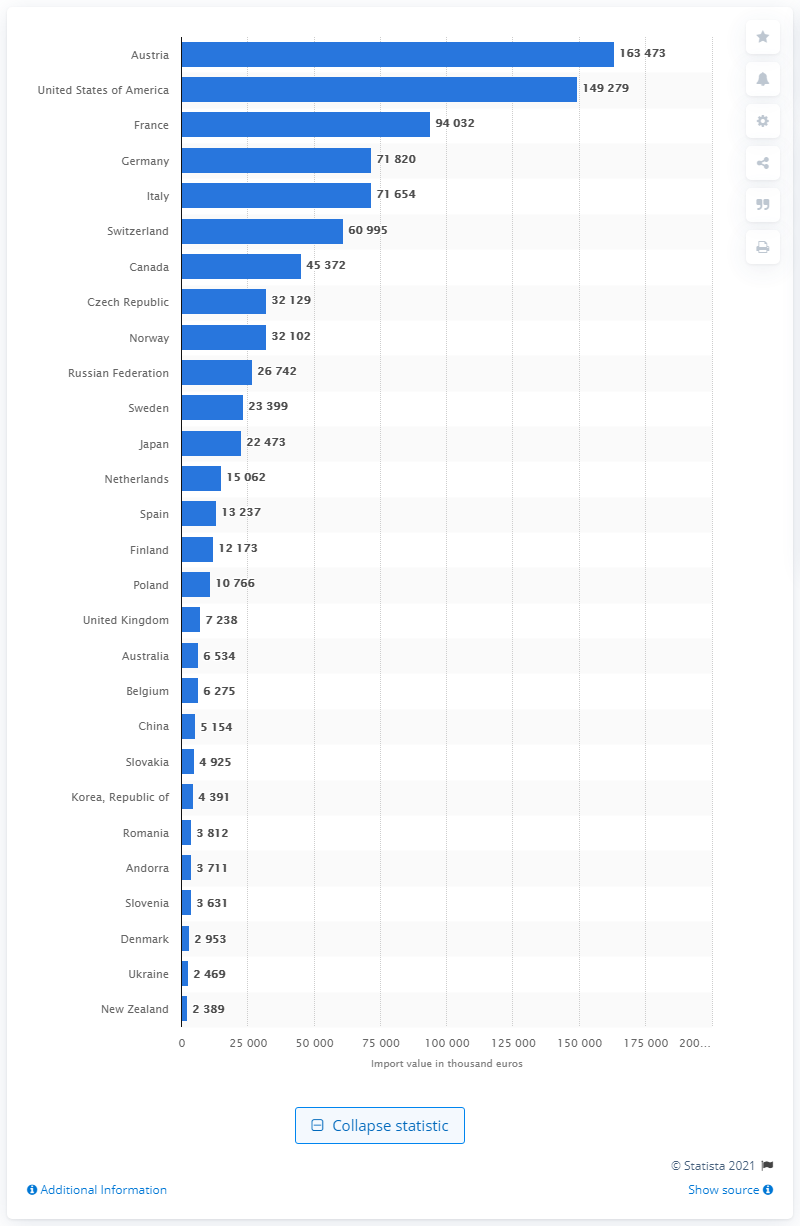Give some essential details in this illustration. Austria had the highest import value of winter skis in 2019. Austria's import value of winter skis in 2019 was 163,473 units. 